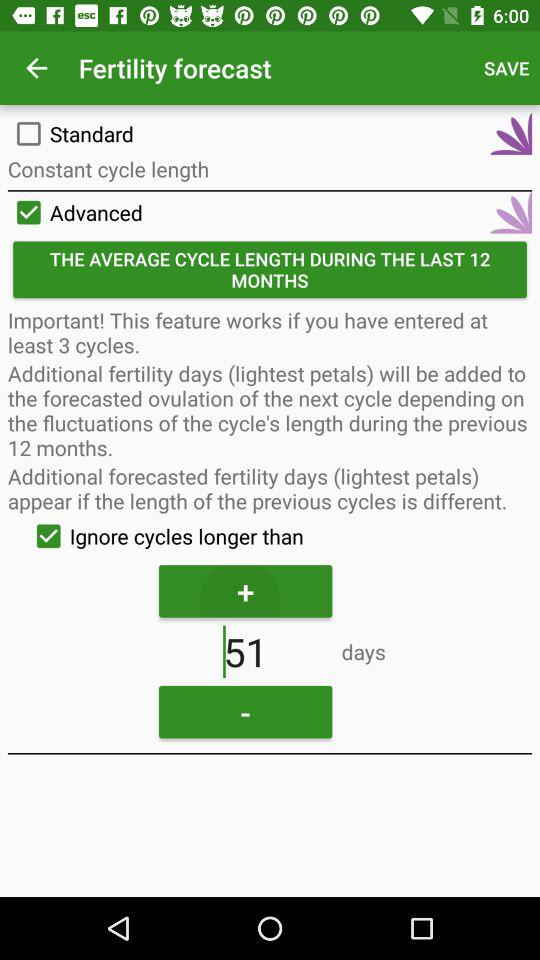What is the status of "Ignore cycles longer than"? The status is "on". 